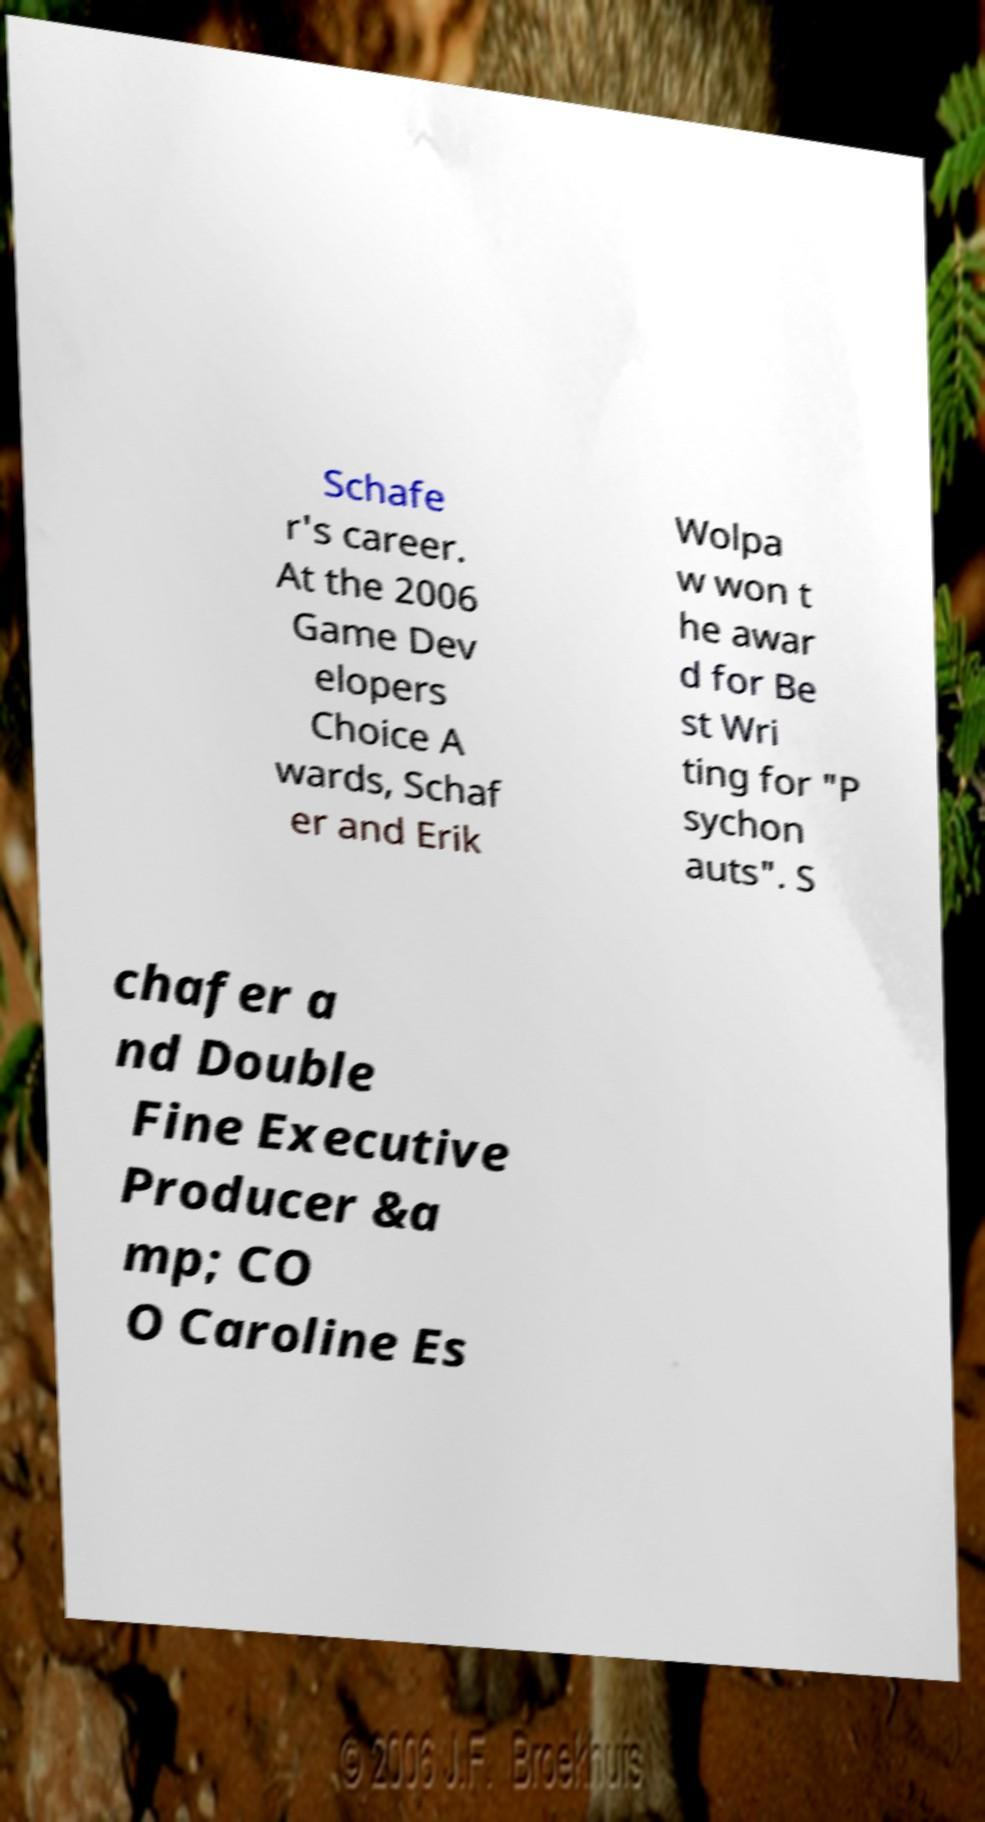There's text embedded in this image that I need extracted. Can you transcribe it verbatim? Schafe r's career. At the 2006 Game Dev elopers Choice A wards, Schaf er and Erik Wolpa w won t he awar d for Be st Wri ting for "P sychon auts". S chafer a nd Double Fine Executive Producer &a mp; CO O Caroline Es 